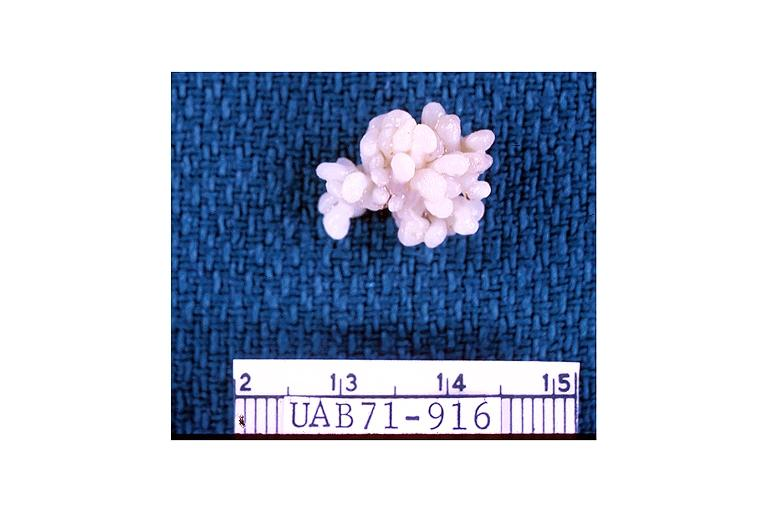what does this image show?
Answer the question using a single word or phrase. Papilloma 